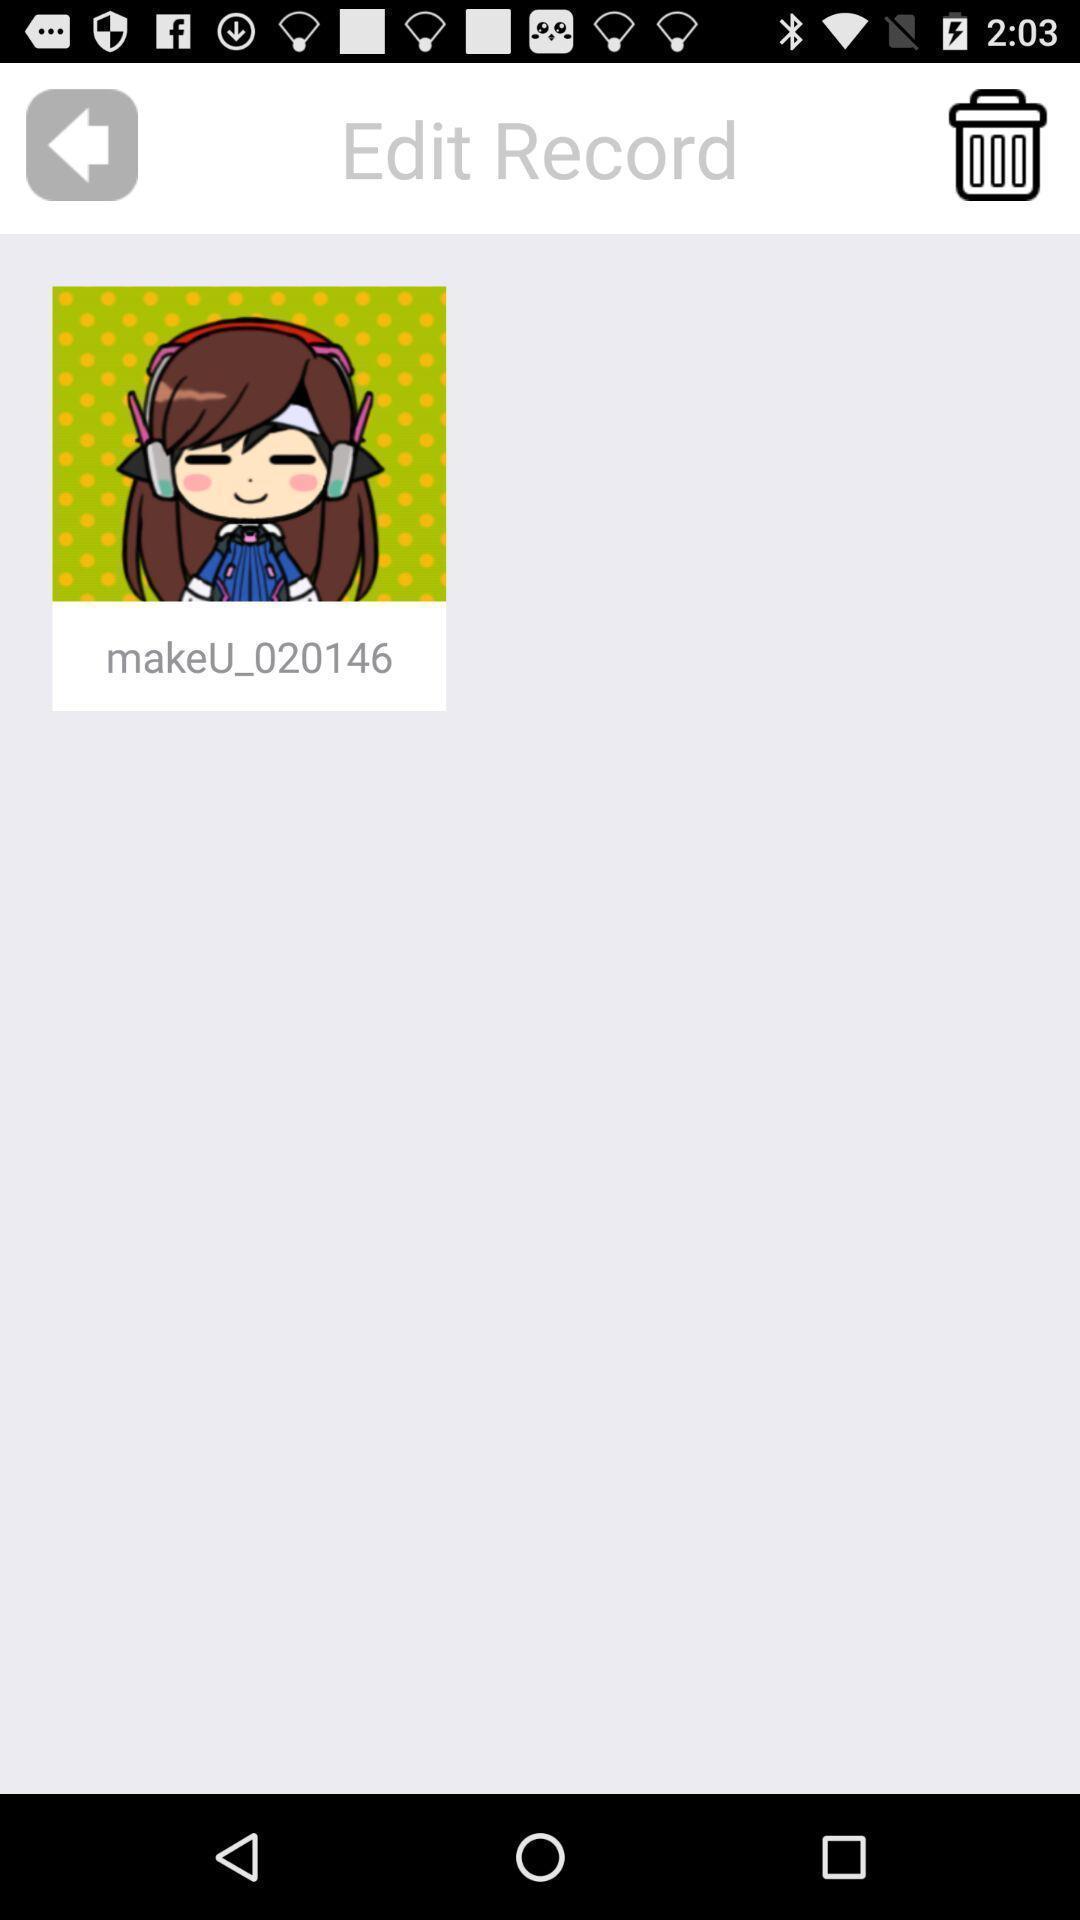Describe the visual elements of this screenshot. Screen showing an image. 